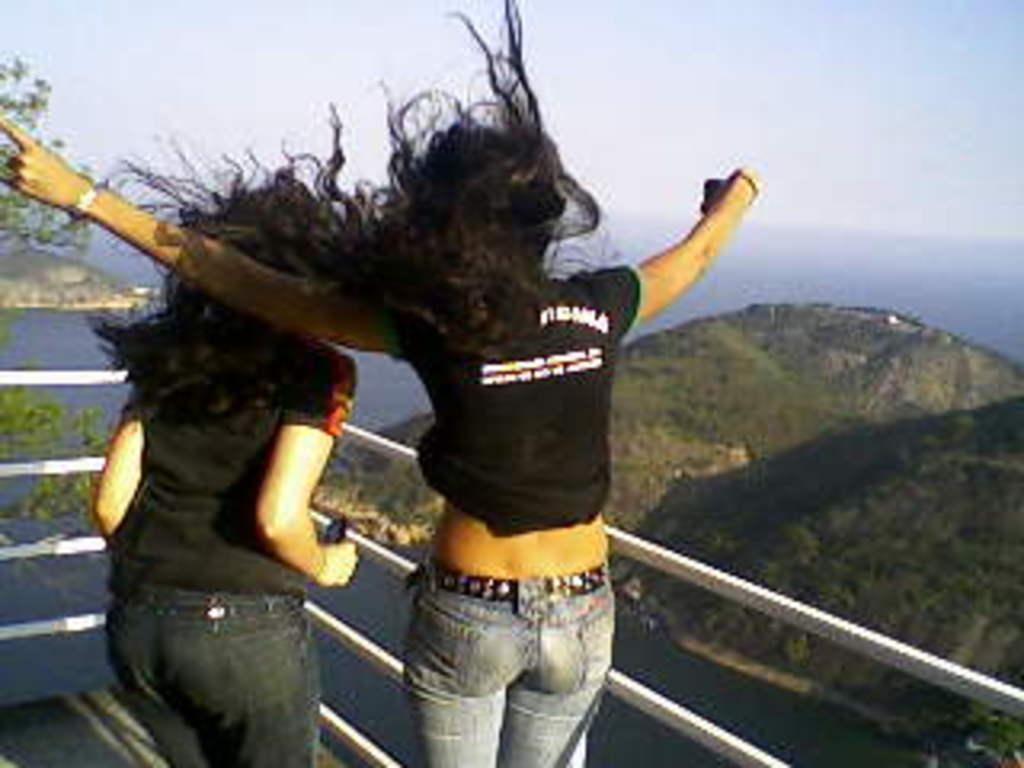How would you summarize this image in a sentence or two? This picture is clicked outside. In the center we can see the two persons wearing black color t-shirts and standing and we can see a guard rail. In the background there is a sky, trees and some other objects. 